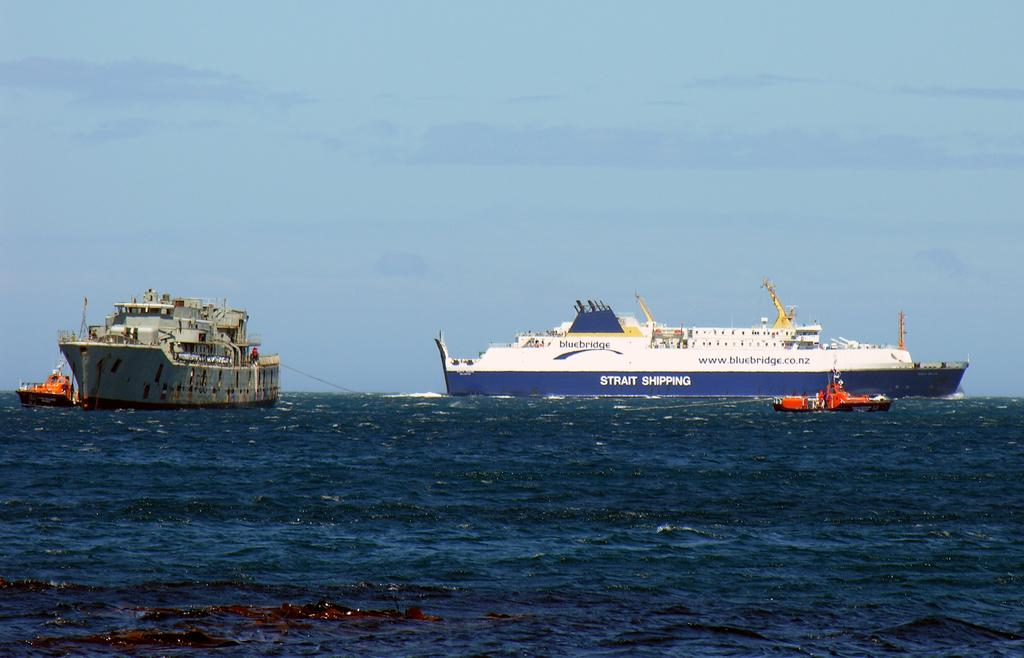What type of vehicles are in the image? There are ships in the image. Where are the ships located? The ships are on the water. What type of machine is used to play baseball in the image? There is no machine or baseball game present in the image; it features ships on the water. 